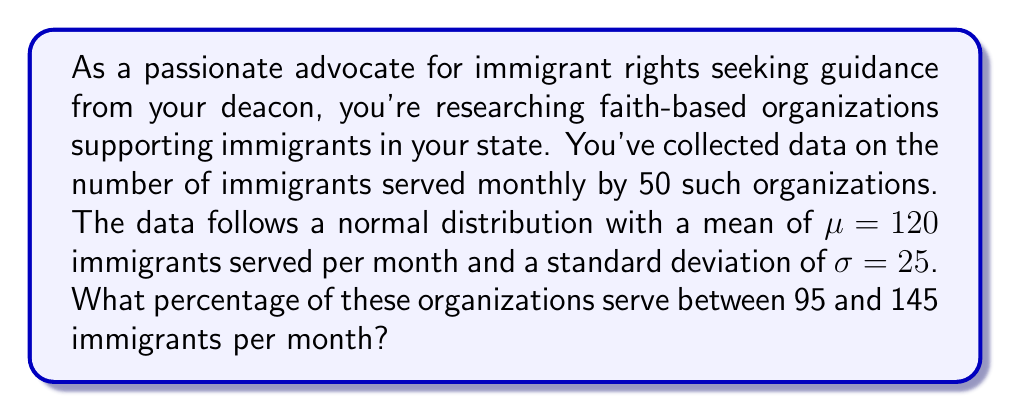Help me with this question. To solve this problem, we need to use the properties of the normal distribution and the concept of z-scores.

1. First, let's calculate the z-scores for the lower and upper bounds of our range:

   For 95 immigrants: $z_1 = \frac{95 - 120}{25} = -1$
   For 145 immigrants: $z_2 = \frac{145 - 120}{25} = 1$

2. Now, we need to find the area under the standard normal curve between these two z-scores. This area represents the probability of an organization serving between 95 and 145 immigrants per month.

3. We can use the standard normal distribution table or a calculator to find the area between z = -1 and z = 1.

4. The area under the standard normal curve between z = -1 and z = 1 is approximately 0.6826, or 68.26%.

5. This means that 68.26% of the organizations serve between 95 and 145 immigrants per month.

6. To convert this to a percentage, we multiply by 100:
   
   $68.26\% \approx 68.3\%$ (rounded to one decimal place)

This result aligns with the empirical rule (68-95-99.7 rule) for normal distributions, which states that approximately 68% of the data falls within one standard deviation of the mean.
Answer: Approximately 68.3% of the faith-based organizations serve between 95 and 145 immigrants per month. 